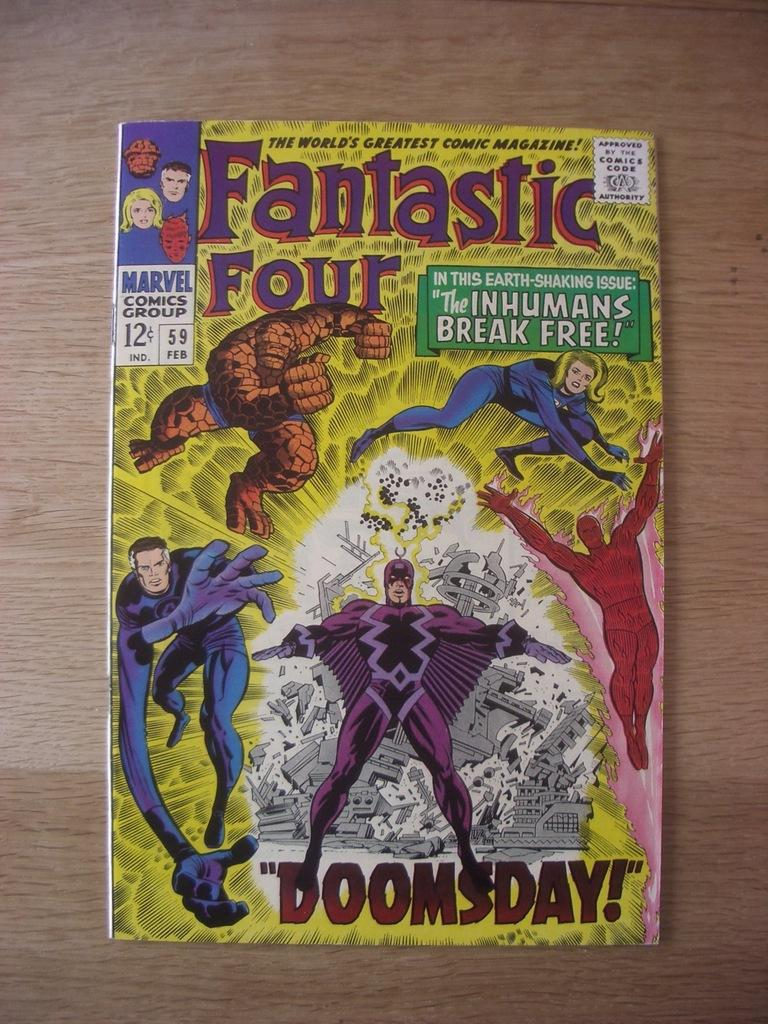<image>
Write a terse but informative summary of the picture. A fantastic four comic book titled Doomsday from Marvel 